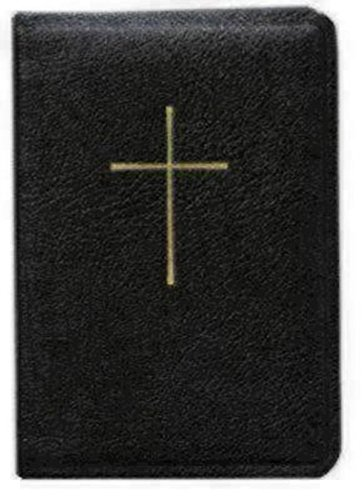Is this christianity book? Yes, the cross symbol on the cover is indicative of Christian literature, suggesting that this book is related to Christianity, typically encompassing sacred texts, prayers, or hymns used in worship. 